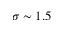<formula> <loc_0><loc_0><loc_500><loc_500>\sigma \sim 1 . 5</formula> 